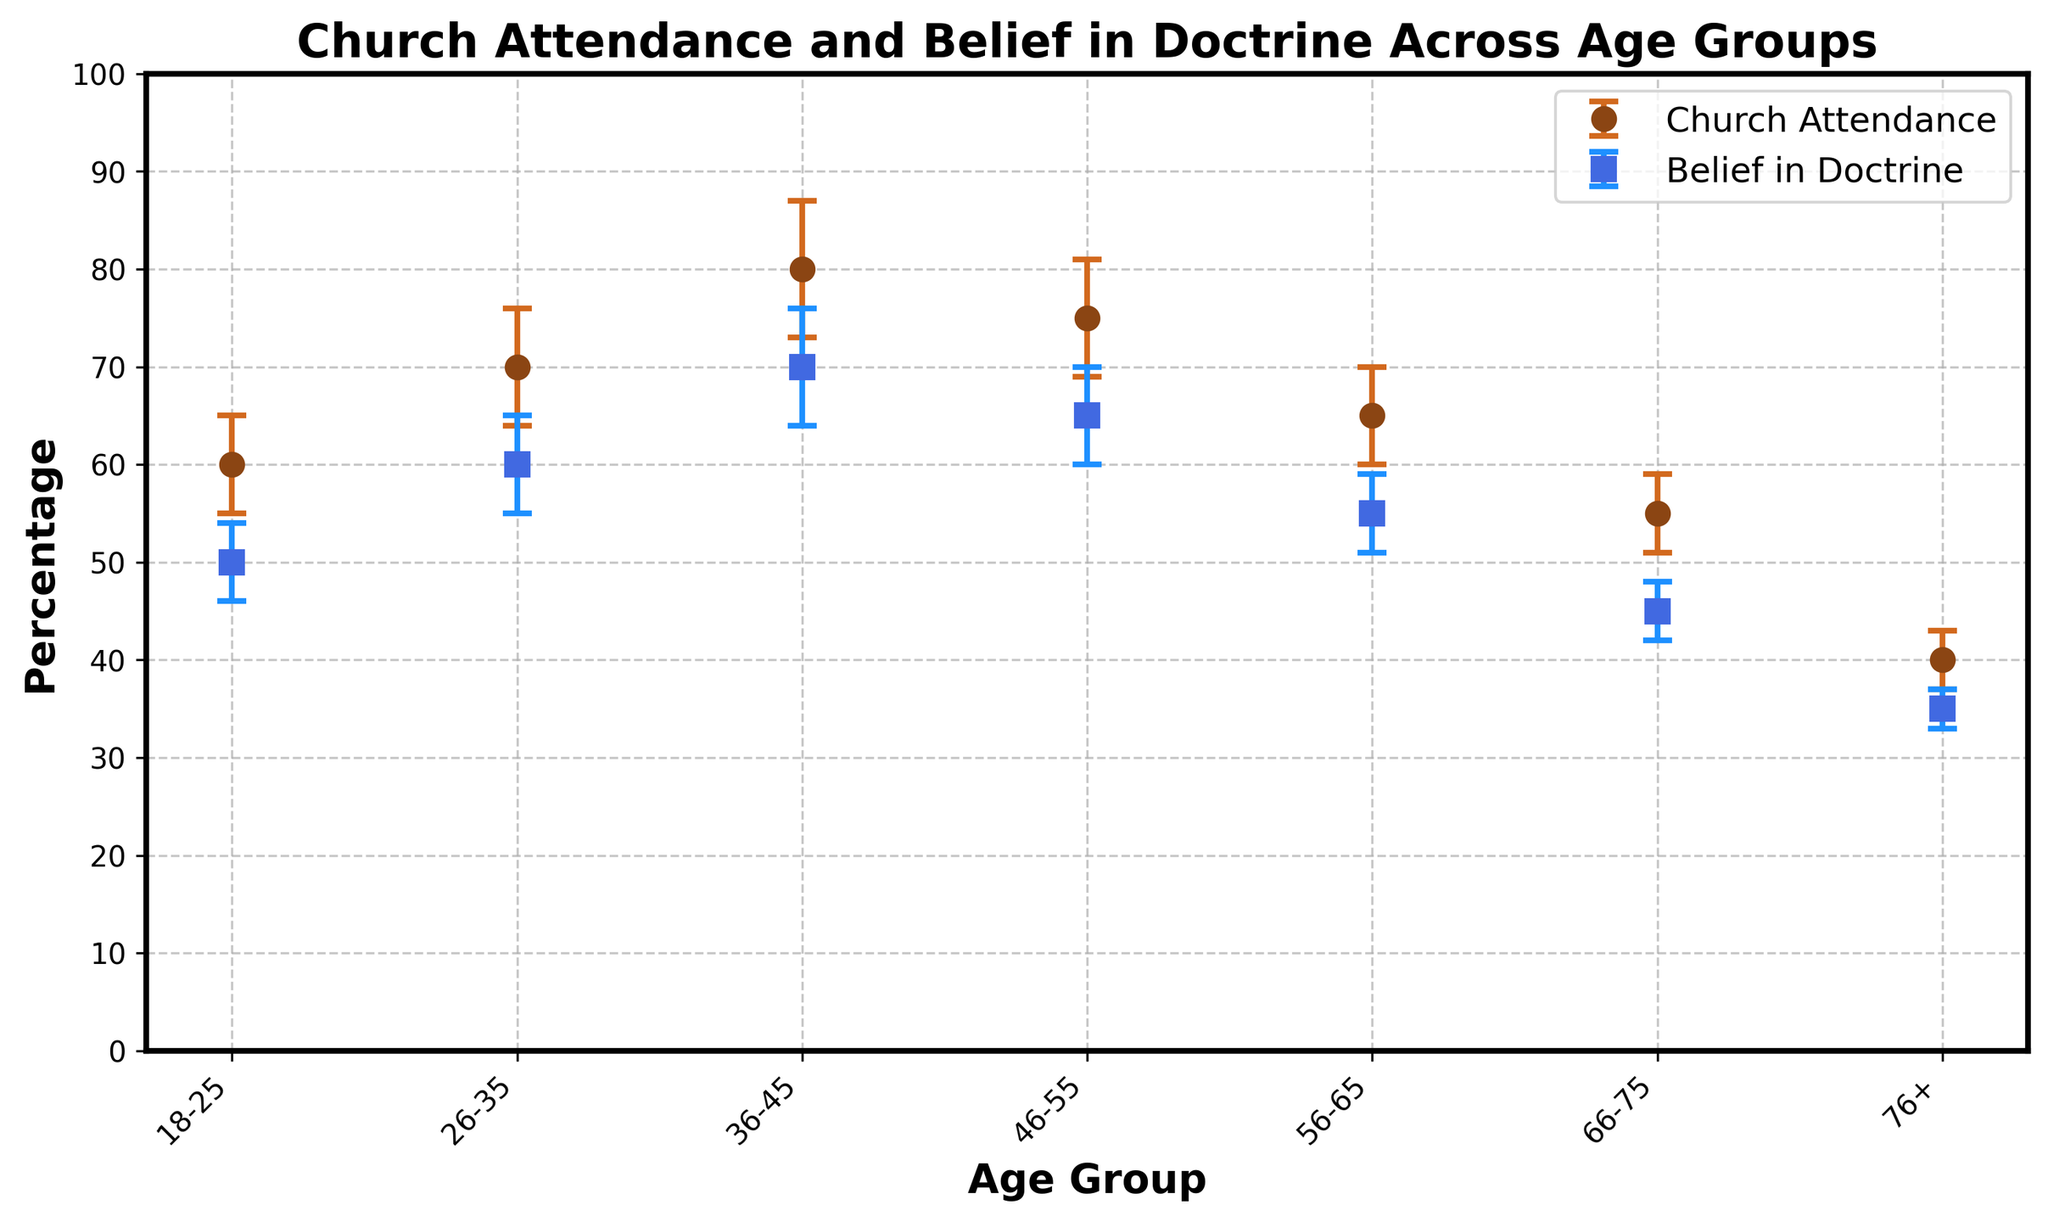what are the age groups listed along the x-axis? The x-axis represents different age groups. By looking at the x-axis labels, we identify the age groups. They are 18-25, 26-35, 36-45, 46-55, 56-65, 66-75, and 76+.
Answer: 18-25, 26-35, 36-45, 46-55, 56-65, 66-75, 76+ What is the percentage of church attendance in the 36-45 age group? By locating the point of the 36-45 age group for church attendance, we see the corresponding value on the y-axis. The scatter plot indicates this value directly.
Answer: 80% Which age group shows the highest belief in doctrine? Comparing all the data points for belief in doctrine across different age groups, the highest y-value is evident at the 36-45 age group.
Answer: 36-45 How much higher is the church attendance compared to belief in doctrine for the 56-65 age group? Church attendance is 65%, and belief in doctrine is 55% for the 56-65 age group. The difference is 65% - 55%.
Answer: 10% Which age group has the lowest uncertainty for church attendance? The error bars indicate uncertainty. By examining the length of these bars on the church attendance line, the shortest one corresponds to the 76+ age group.
Answer: 76+ What is the range of church attendance for the 26-35 age group if we consider uncertainty? The church attendance is 70%, with an uncertainty of ±6%. So, the range spans from 70% - 6% to 70% + 6%.
Answer: 64% to 76% Do individuals over 75 have a greater church attendance or belief in doctrine? Comparing the data points for the 76+ age group, church attendance is 40% and belief in doctrine is 35%.
Answer: Church attendance What trend can be observed in church attendance as the age group increases from 18-25 to 76+? Church attendance initially increases, peaks at the 36-45 age group, and then declines steadily as the age group increases further.
Answer: Initially increases, then declines How consistent (i.e., with low measurement uncertainty) are the reported beliefs in doctrine across all age groups? By examining the error bars on the belief in doctrine points, we observe that most points have relatively short error bars, indicating consistent measurements.
Answer: Consistent Considering both church attendance and belief in doctrine, which age group shows the least disparity between the two? Calculating the absolute differences between corresponding values for both church attendance and belief in doctrine across all age groups, the 76+ age group shows the smallest disparity (40% - 35%).
Answer: 76+ 